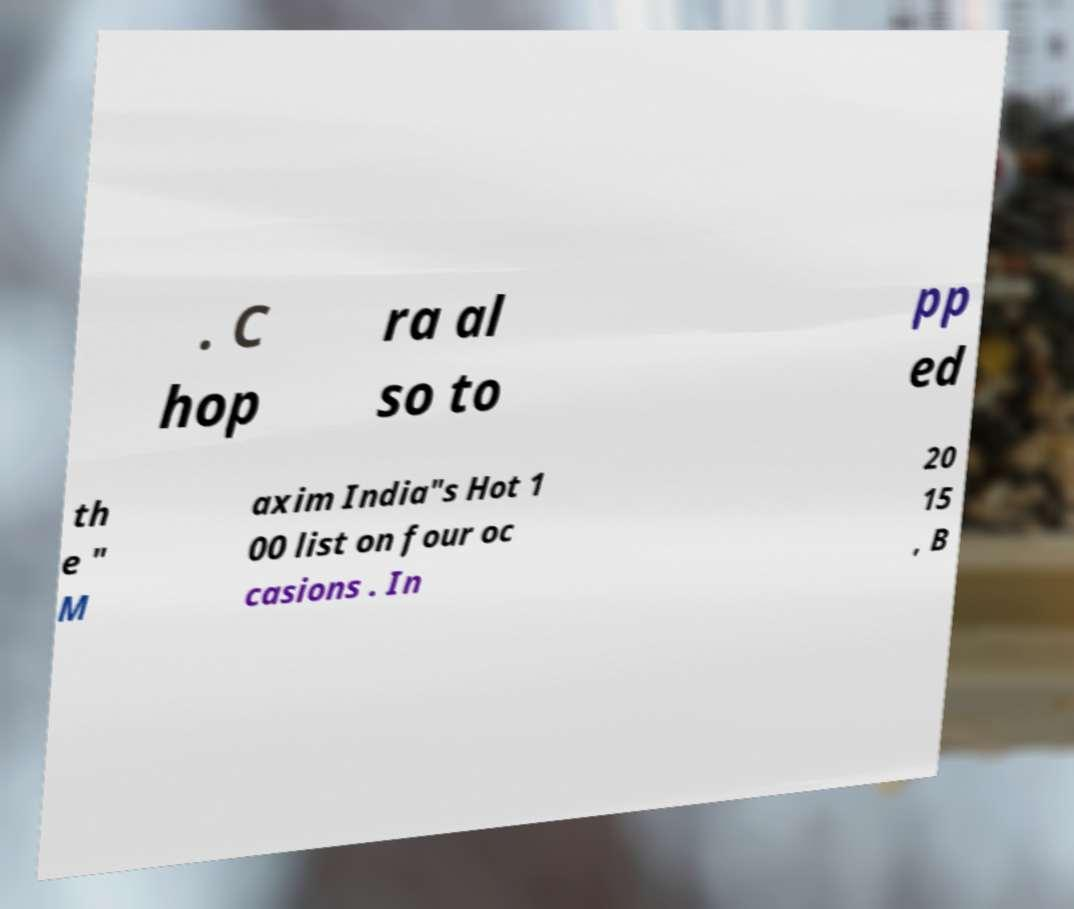What messages or text are displayed in this image? I need them in a readable, typed format. . C hop ra al so to pp ed th e " M axim India"s Hot 1 00 list on four oc casions . In 20 15 , B 